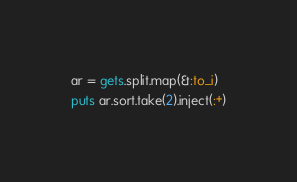Convert code to text. <code><loc_0><loc_0><loc_500><loc_500><_Ruby_>ar = gets.split.map(&:to_i)
puts ar.sort.take(2).inject(:+)</code> 